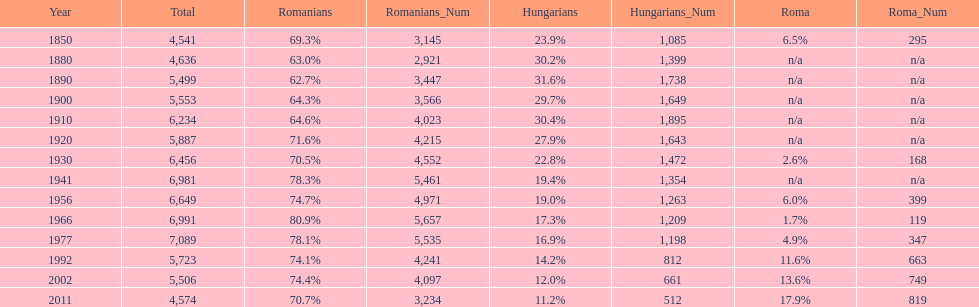Which year had the top percentage in romanian population? 1966. 